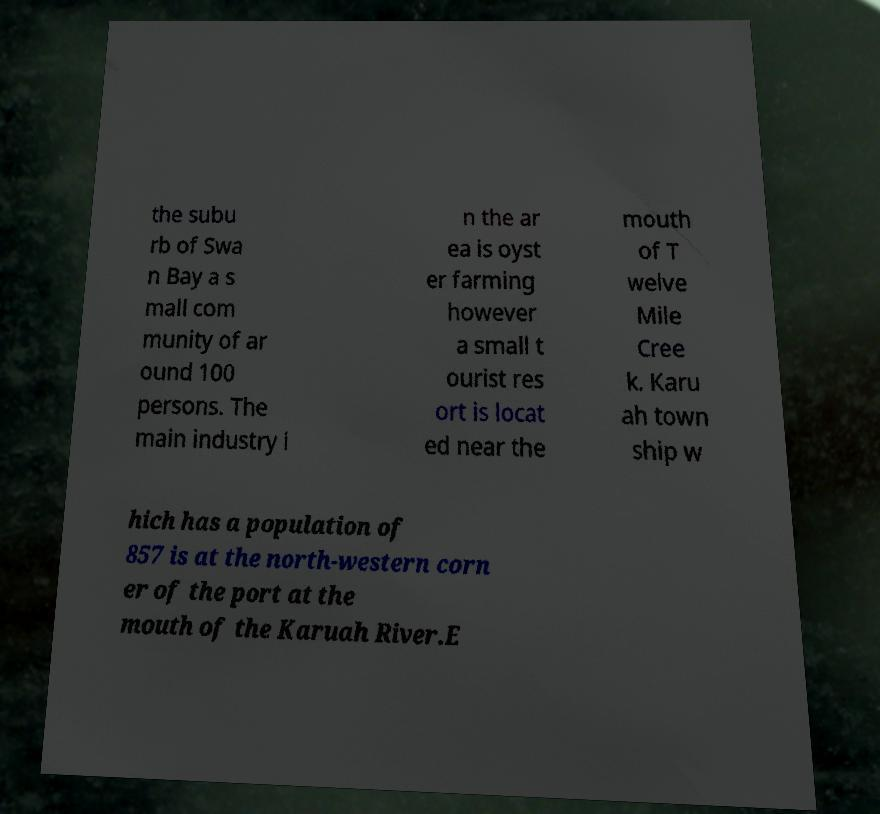Could you assist in decoding the text presented in this image and type it out clearly? the subu rb of Swa n Bay a s mall com munity of ar ound 100 persons. The main industry i n the ar ea is oyst er farming however a small t ourist res ort is locat ed near the mouth of T welve Mile Cree k. Karu ah town ship w hich has a population of 857 is at the north-western corn er of the port at the mouth of the Karuah River.E 